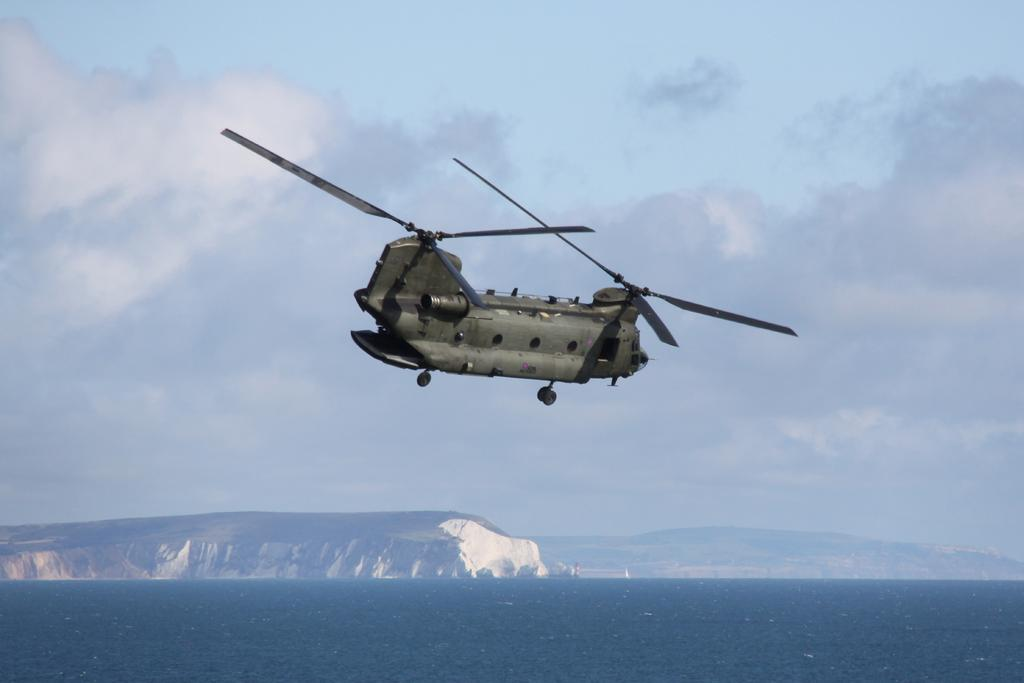What type of aircraft is in the image? There is a Chinook helicopter in the image. Where is the helicopter located in the image? The helicopter is in the air. What is visible at the bottom of the image? There is a river at the bottom of the image. What can be seen in the background of the image? There are mountains and the sky visible in the background of the image. What type of leather is used to make the cord for the sheet in the image? There is no leather, cord, or sheet present in the image. 